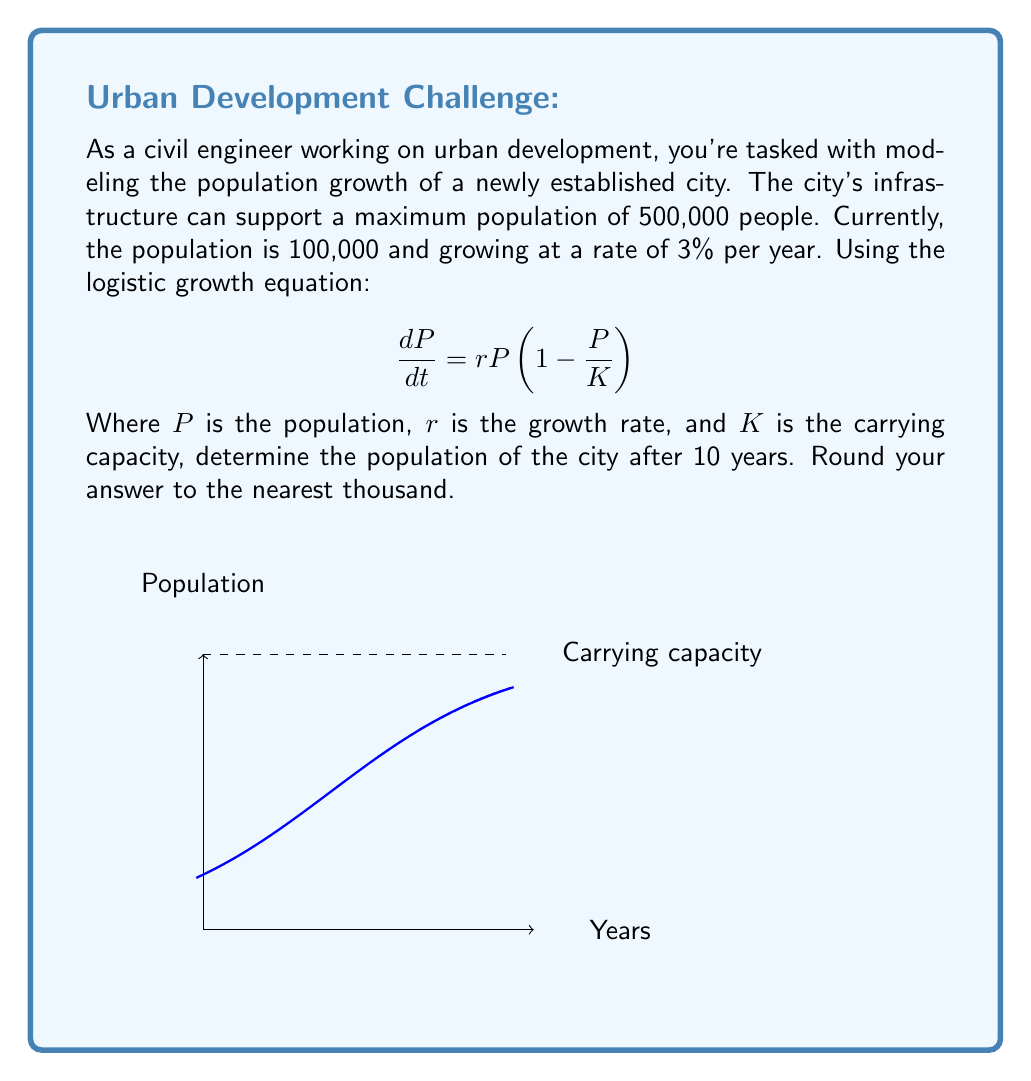What is the answer to this math problem? Let's approach this step-by-step:

1) We're given:
   - Initial population, $P_0 = 100,000$
   - Growth rate, $r = 0.03$ (3% per year)
   - Carrying capacity, $K = 500,000$
   - Time, $t = 10$ years

2) The solution to the logistic growth equation is:

   $$P(t) = \frac{K}{1 + (\frac{K}{P_0} - 1)e^{-rt}}$$

3) Let's substitute our values:

   $$P(10) = \frac{500,000}{1 + (\frac{500,000}{100,000} - 1)e^{-0.03(10)}}$$

4) Simplify:
   $$P(10) = \frac{500,000}{1 + 4e^{-0.3}}$$

5) Calculate:
   $$P(10) = \frac{500,000}{1 + 4(0.7408)}$$
   $$P(10) = \frac{500,000}{3.9632}$$
   $$P(10) = 126,161.18$$

6) Rounding to the nearest thousand:
   $$P(10) \approx 126,000$$
Answer: 126,000 